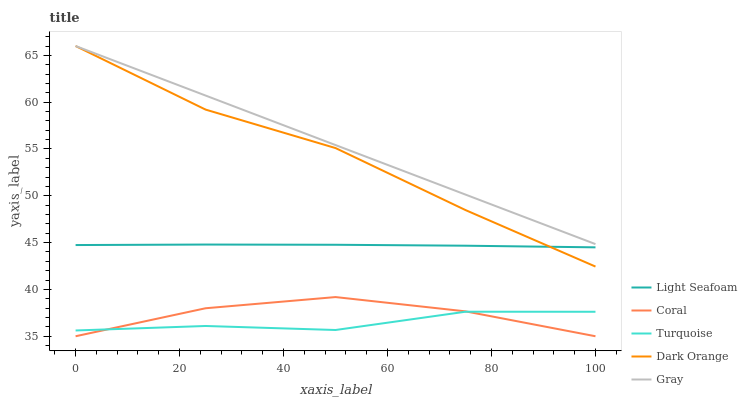Does Turquoise have the minimum area under the curve?
Answer yes or no. Yes. Does Gray have the maximum area under the curve?
Answer yes or no. Yes. Does Coral have the minimum area under the curve?
Answer yes or no. No. Does Coral have the maximum area under the curve?
Answer yes or no. No. Is Gray the smoothest?
Answer yes or no. Yes. Is Dark Orange the roughest?
Answer yes or no. Yes. Is Coral the smoothest?
Answer yes or no. No. Is Coral the roughest?
Answer yes or no. No. Does Coral have the lowest value?
Answer yes or no. Yes. Does Light Seafoam have the lowest value?
Answer yes or no. No. Does Gray have the highest value?
Answer yes or no. Yes. Does Coral have the highest value?
Answer yes or no. No. Is Turquoise less than Light Seafoam?
Answer yes or no. Yes. Is Light Seafoam greater than Turquoise?
Answer yes or no. Yes. Does Gray intersect Dark Orange?
Answer yes or no. Yes. Is Gray less than Dark Orange?
Answer yes or no. No. Is Gray greater than Dark Orange?
Answer yes or no. No. Does Turquoise intersect Light Seafoam?
Answer yes or no. No. 